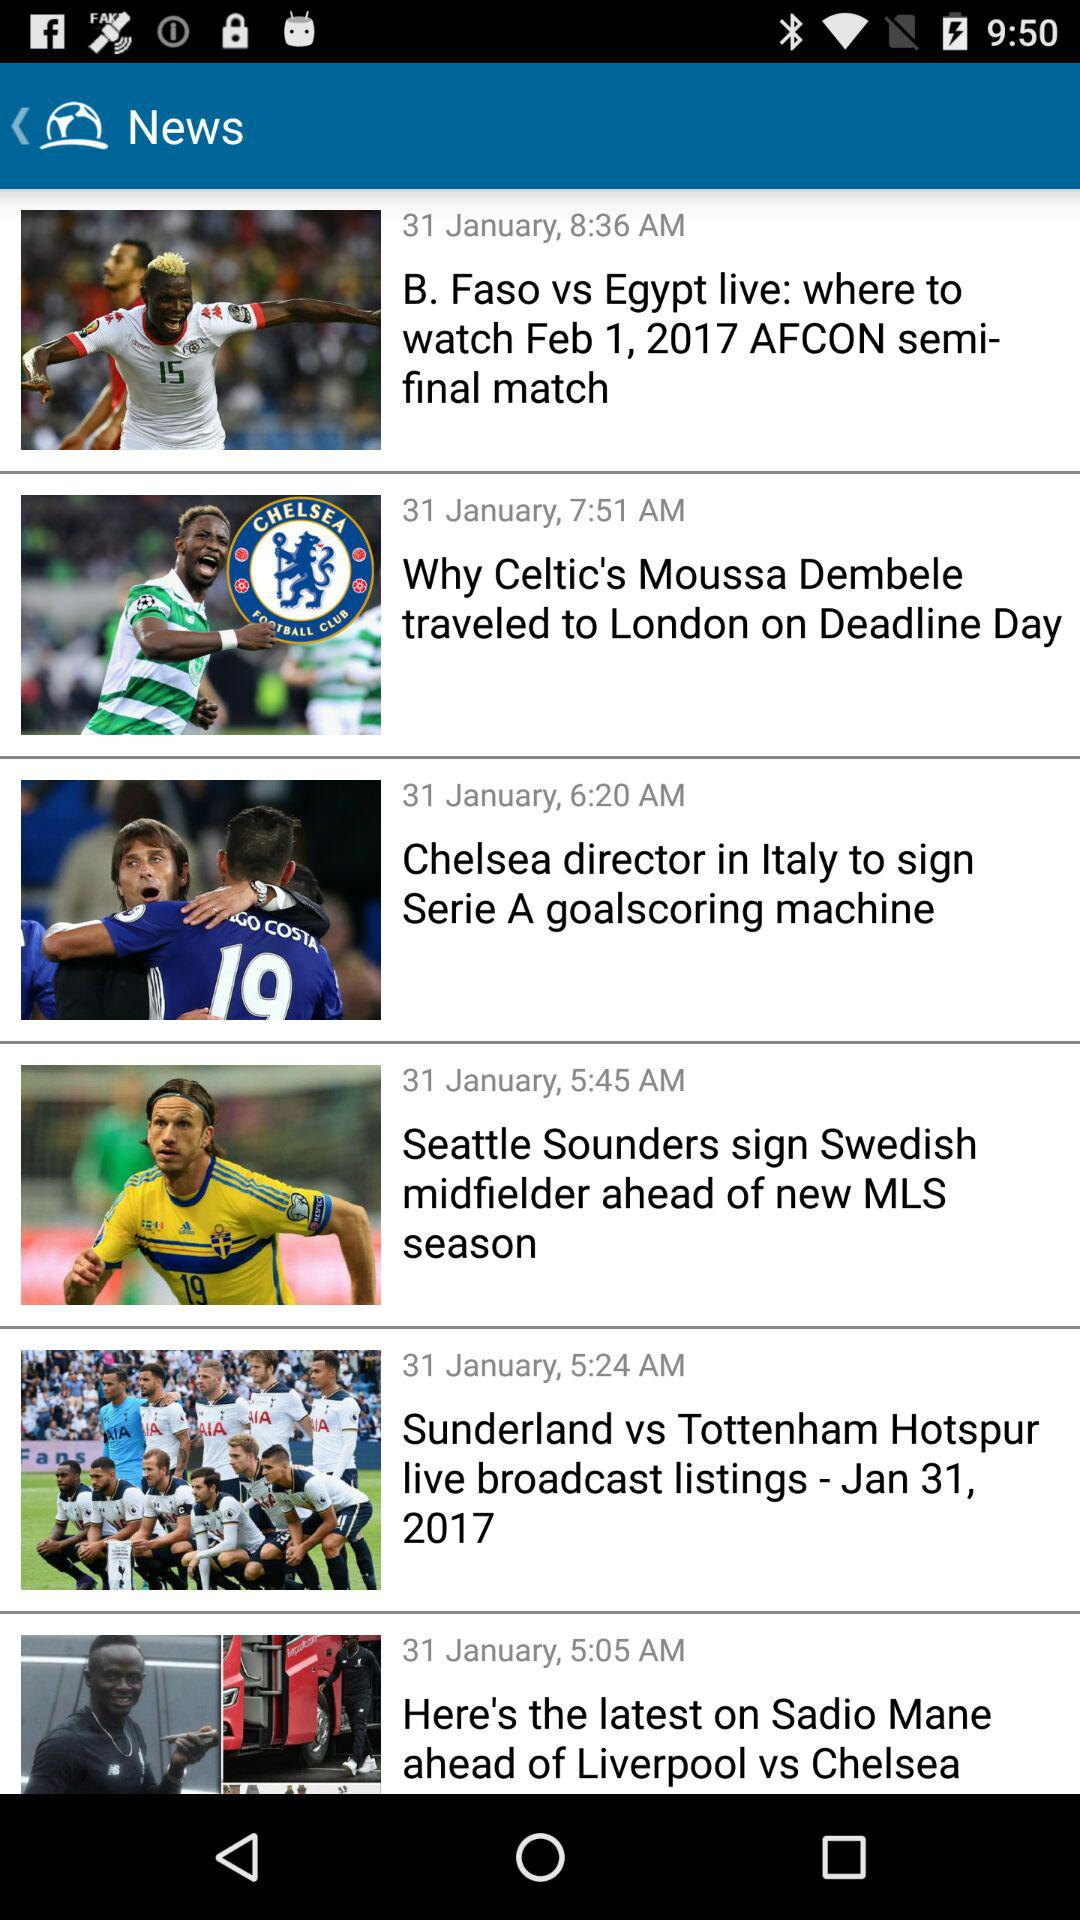What date is reflected on the screen? The date reflected on the screen is January 31. 